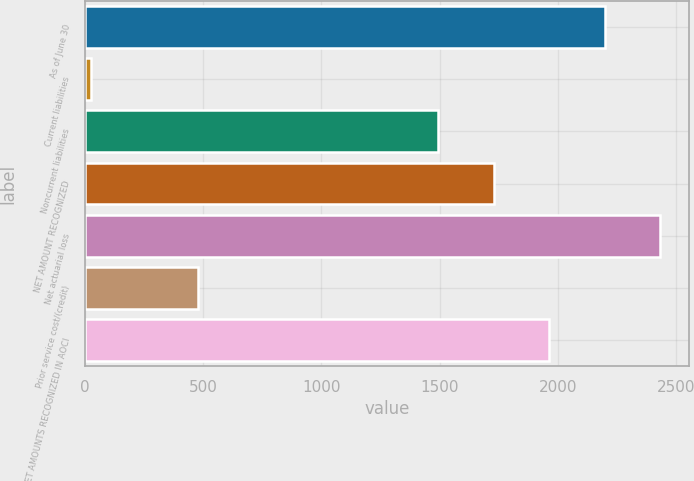Convert chart to OTSL. <chart><loc_0><loc_0><loc_500><loc_500><bar_chart><fcel>As of June 30<fcel>Current liabilities<fcel>Noncurrent liabilities<fcel>NET AMOUNT RECOGNIZED<fcel>Net actuarial loss<fcel>Prior service cost/(credit)<fcel>NET AMOUNTS RECOGNIZED IN AOCI<nl><fcel>2197.6<fcel>24<fcel>1495<fcel>1729.2<fcel>2431.8<fcel>478<fcel>1963.4<nl></chart> 